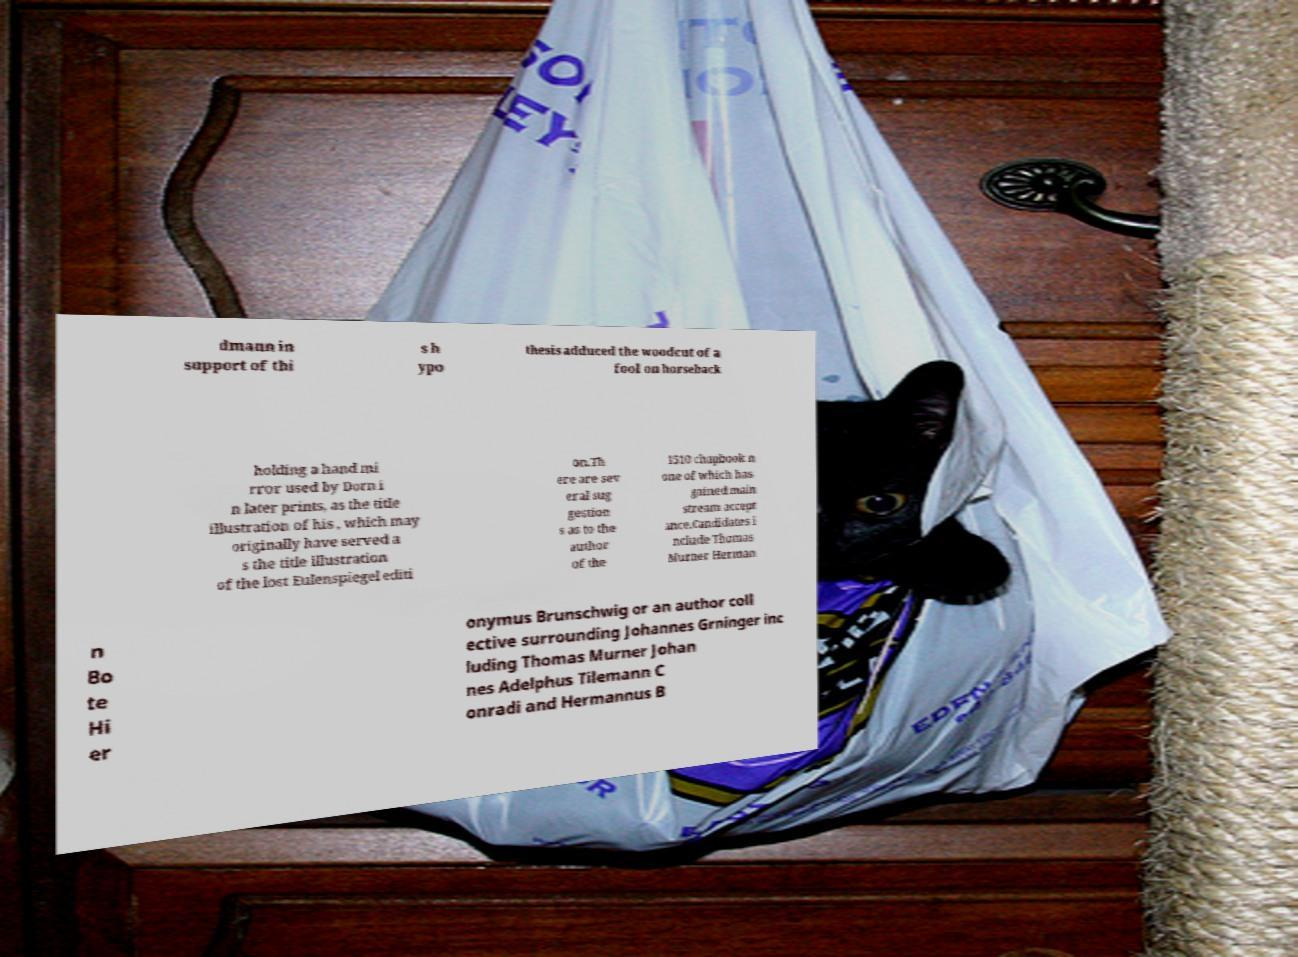What messages or text are displayed in this image? I need them in a readable, typed format. dmann in support of thi s h ypo thesis adduced the woodcut of a fool on horseback holding a hand mi rror used by Dorn i n later prints, as the title illustration of his , which may originally have served a s the title illustration of the lost Eulenspiegel editi on.Th ere are sev eral sug gestion s as to the author of the 1510 chapbook n one of which has gained main stream accept ance.Candidates i nclude Thomas Murner Herman n Bo te Hi er onymus Brunschwig or an author coll ective surrounding Johannes Grninger inc luding Thomas Murner Johan nes Adelphus Tilemann C onradi and Hermannus B 